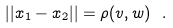<formula> <loc_0><loc_0><loc_500><loc_500>| | x _ { 1 } - x _ { 2 } | | = \rho ( v , w ) \ .</formula> 